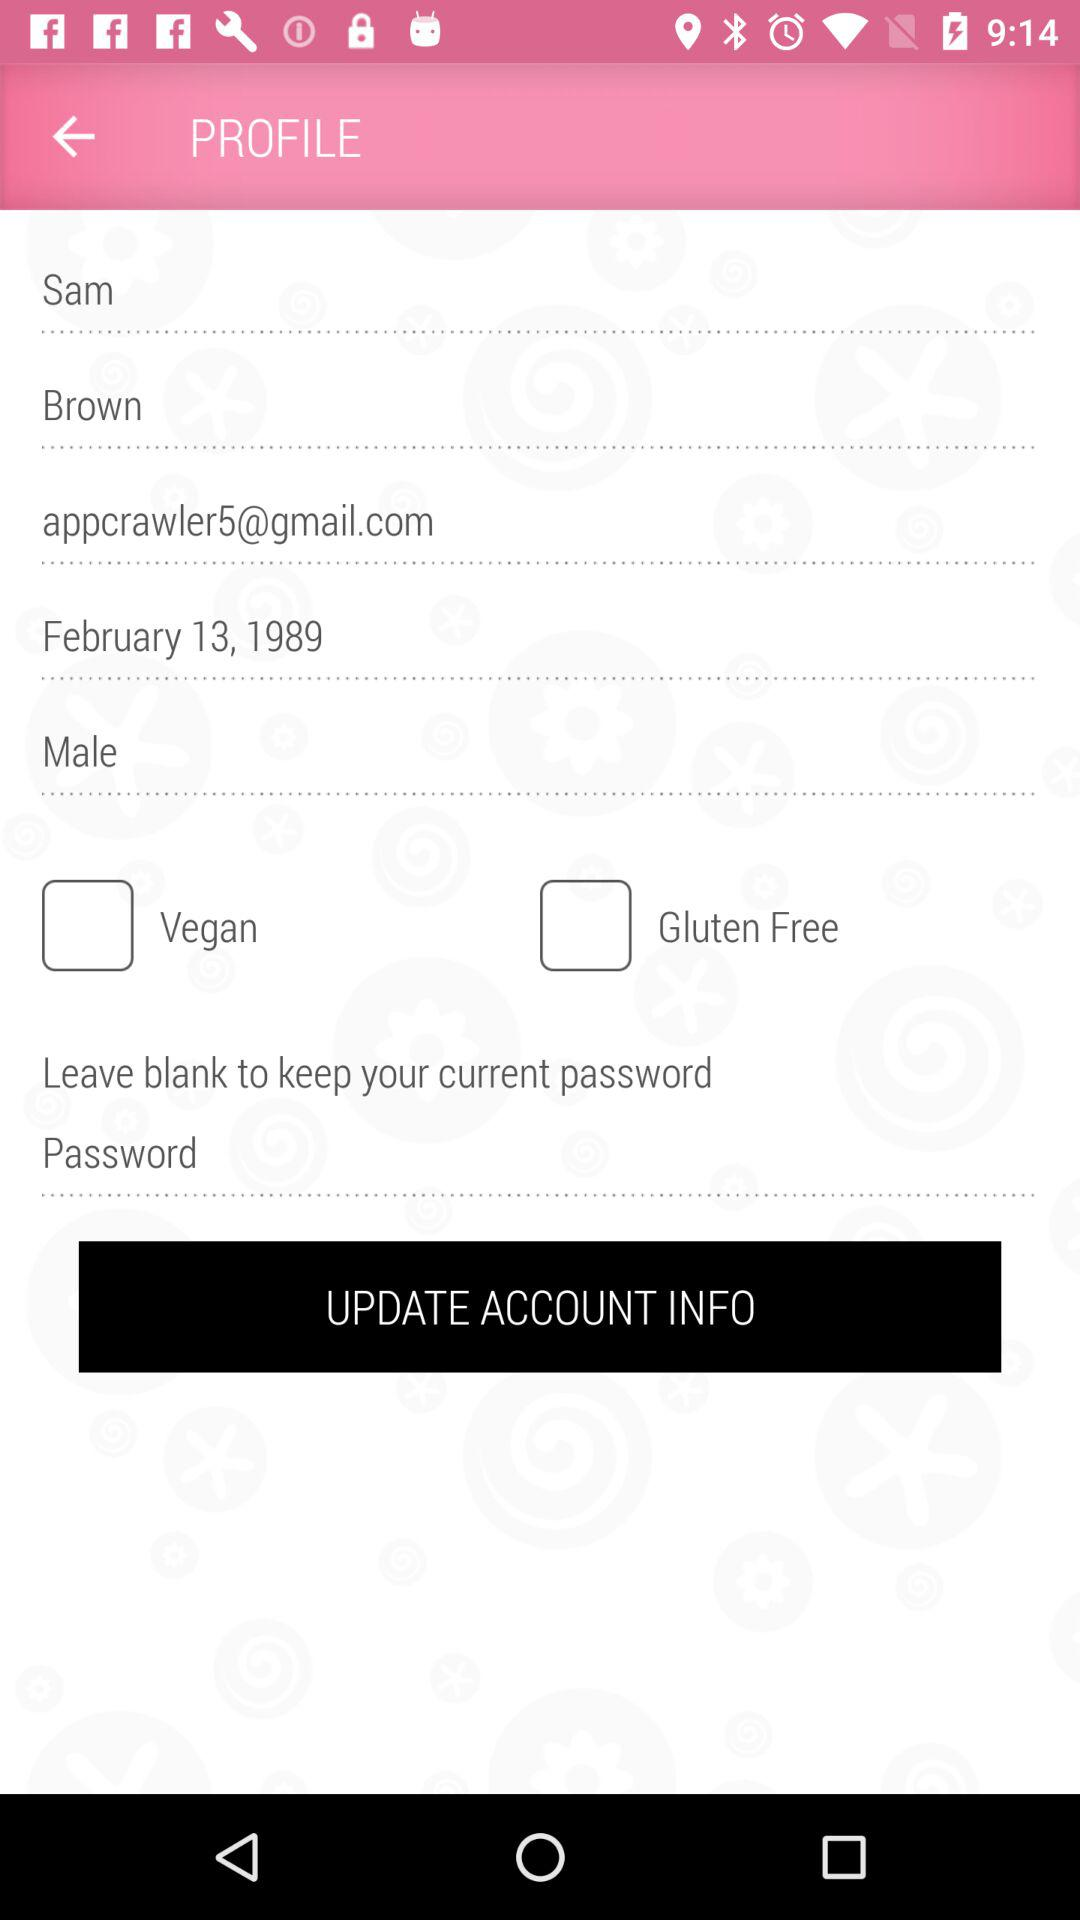What is the mentioned birthdate? The mentioned birthdate is February 13, 1989. 